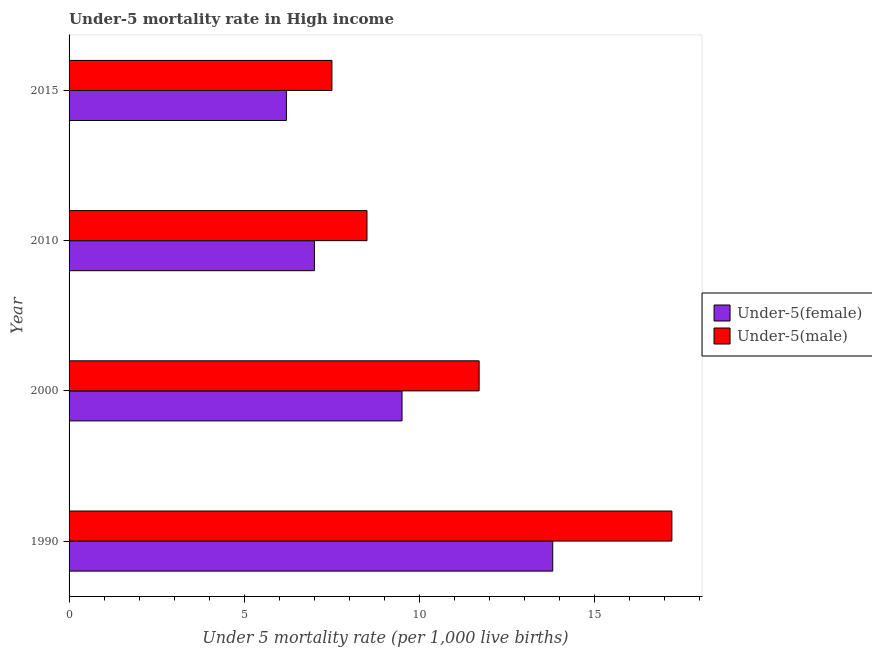Are the number of bars per tick equal to the number of legend labels?
Offer a very short reply. Yes. How many bars are there on the 3rd tick from the top?
Make the answer very short. 2. In how many cases, is the number of bars for a given year not equal to the number of legend labels?
Your answer should be very brief. 0. What is the under-5 female mortality rate in 2000?
Offer a very short reply. 9.5. Across all years, what is the minimum under-5 male mortality rate?
Your answer should be very brief. 7.5. In which year was the under-5 female mortality rate minimum?
Your response must be concise. 2015. What is the total under-5 male mortality rate in the graph?
Offer a very short reply. 44.9. What is the difference between the under-5 male mortality rate in 1990 and the under-5 female mortality rate in 2015?
Ensure brevity in your answer.  11. What is the average under-5 female mortality rate per year?
Offer a terse response. 9.12. In how many years, is the under-5 female mortality rate greater than 15 ?
Provide a succinct answer. 0. What is the ratio of the under-5 female mortality rate in 1990 to that in 2000?
Give a very brief answer. 1.45. Is the under-5 female mortality rate in 1990 less than that in 2010?
Offer a terse response. No. Is the difference between the under-5 female mortality rate in 1990 and 2000 greater than the difference between the under-5 male mortality rate in 1990 and 2000?
Keep it short and to the point. No. What does the 1st bar from the top in 2010 represents?
Your answer should be very brief. Under-5(male). What does the 2nd bar from the bottom in 2000 represents?
Your answer should be compact. Under-5(male). Are all the bars in the graph horizontal?
Your answer should be compact. Yes. Are the values on the major ticks of X-axis written in scientific E-notation?
Keep it short and to the point. No. Does the graph contain any zero values?
Provide a succinct answer. No. Where does the legend appear in the graph?
Your answer should be very brief. Center right. How many legend labels are there?
Offer a very short reply. 2. How are the legend labels stacked?
Your answer should be very brief. Vertical. What is the title of the graph?
Ensure brevity in your answer.  Under-5 mortality rate in High income. What is the label or title of the X-axis?
Your answer should be compact. Under 5 mortality rate (per 1,0 live births). What is the Under 5 mortality rate (per 1,000 live births) of Under-5(female) in 1990?
Provide a short and direct response. 13.8. What is the Under 5 mortality rate (per 1,000 live births) of Under-5(female) in 2000?
Provide a short and direct response. 9.5. What is the Under 5 mortality rate (per 1,000 live births) of Under-5(male) in 2000?
Make the answer very short. 11.7. What is the Under 5 mortality rate (per 1,000 live births) in Under-5(female) in 2010?
Offer a very short reply. 7. What is the Under 5 mortality rate (per 1,000 live births) of Under-5(female) in 2015?
Ensure brevity in your answer.  6.2. What is the total Under 5 mortality rate (per 1,000 live births) of Under-5(female) in the graph?
Give a very brief answer. 36.5. What is the total Under 5 mortality rate (per 1,000 live births) of Under-5(male) in the graph?
Your response must be concise. 44.9. What is the difference between the Under 5 mortality rate (per 1,000 live births) of Under-5(male) in 1990 and that in 2000?
Your response must be concise. 5.5. What is the difference between the Under 5 mortality rate (per 1,000 live births) of Under-5(male) in 1990 and that in 2015?
Ensure brevity in your answer.  9.7. What is the difference between the Under 5 mortality rate (per 1,000 live births) in Under-5(female) in 2000 and that in 2010?
Your response must be concise. 2.5. What is the difference between the Under 5 mortality rate (per 1,000 live births) of Under-5(female) in 1990 and the Under 5 mortality rate (per 1,000 live births) of Under-5(male) in 2010?
Offer a terse response. 5.3. What is the difference between the Under 5 mortality rate (per 1,000 live births) in Under-5(female) in 1990 and the Under 5 mortality rate (per 1,000 live births) in Under-5(male) in 2015?
Offer a very short reply. 6.3. What is the average Under 5 mortality rate (per 1,000 live births) in Under-5(female) per year?
Ensure brevity in your answer.  9.12. What is the average Under 5 mortality rate (per 1,000 live births) of Under-5(male) per year?
Give a very brief answer. 11.22. In the year 2000, what is the difference between the Under 5 mortality rate (per 1,000 live births) of Under-5(female) and Under 5 mortality rate (per 1,000 live births) of Under-5(male)?
Provide a short and direct response. -2.2. In the year 2010, what is the difference between the Under 5 mortality rate (per 1,000 live births) of Under-5(female) and Under 5 mortality rate (per 1,000 live births) of Under-5(male)?
Your answer should be very brief. -1.5. In the year 2015, what is the difference between the Under 5 mortality rate (per 1,000 live births) in Under-5(female) and Under 5 mortality rate (per 1,000 live births) in Under-5(male)?
Your answer should be very brief. -1.3. What is the ratio of the Under 5 mortality rate (per 1,000 live births) in Under-5(female) in 1990 to that in 2000?
Keep it short and to the point. 1.45. What is the ratio of the Under 5 mortality rate (per 1,000 live births) of Under-5(male) in 1990 to that in 2000?
Provide a succinct answer. 1.47. What is the ratio of the Under 5 mortality rate (per 1,000 live births) of Under-5(female) in 1990 to that in 2010?
Your response must be concise. 1.97. What is the ratio of the Under 5 mortality rate (per 1,000 live births) of Under-5(male) in 1990 to that in 2010?
Ensure brevity in your answer.  2.02. What is the ratio of the Under 5 mortality rate (per 1,000 live births) in Under-5(female) in 1990 to that in 2015?
Ensure brevity in your answer.  2.23. What is the ratio of the Under 5 mortality rate (per 1,000 live births) in Under-5(male) in 1990 to that in 2015?
Ensure brevity in your answer.  2.29. What is the ratio of the Under 5 mortality rate (per 1,000 live births) in Under-5(female) in 2000 to that in 2010?
Ensure brevity in your answer.  1.36. What is the ratio of the Under 5 mortality rate (per 1,000 live births) in Under-5(male) in 2000 to that in 2010?
Your answer should be very brief. 1.38. What is the ratio of the Under 5 mortality rate (per 1,000 live births) in Under-5(female) in 2000 to that in 2015?
Ensure brevity in your answer.  1.53. What is the ratio of the Under 5 mortality rate (per 1,000 live births) of Under-5(male) in 2000 to that in 2015?
Give a very brief answer. 1.56. What is the ratio of the Under 5 mortality rate (per 1,000 live births) in Under-5(female) in 2010 to that in 2015?
Ensure brevity in your answer.  1.13. What is the ratio of the Under 5 mortality rate (per 1,000 live births) in Under-5(male) in 2010 to that in 2015?
Provide a succinct answer. 1.13. What is the difference between the highest and the second highest Under 5 mortality rate (per 1,000 live births) in Under-5(female)?
Ensure brevity in your answer.  4.3. 